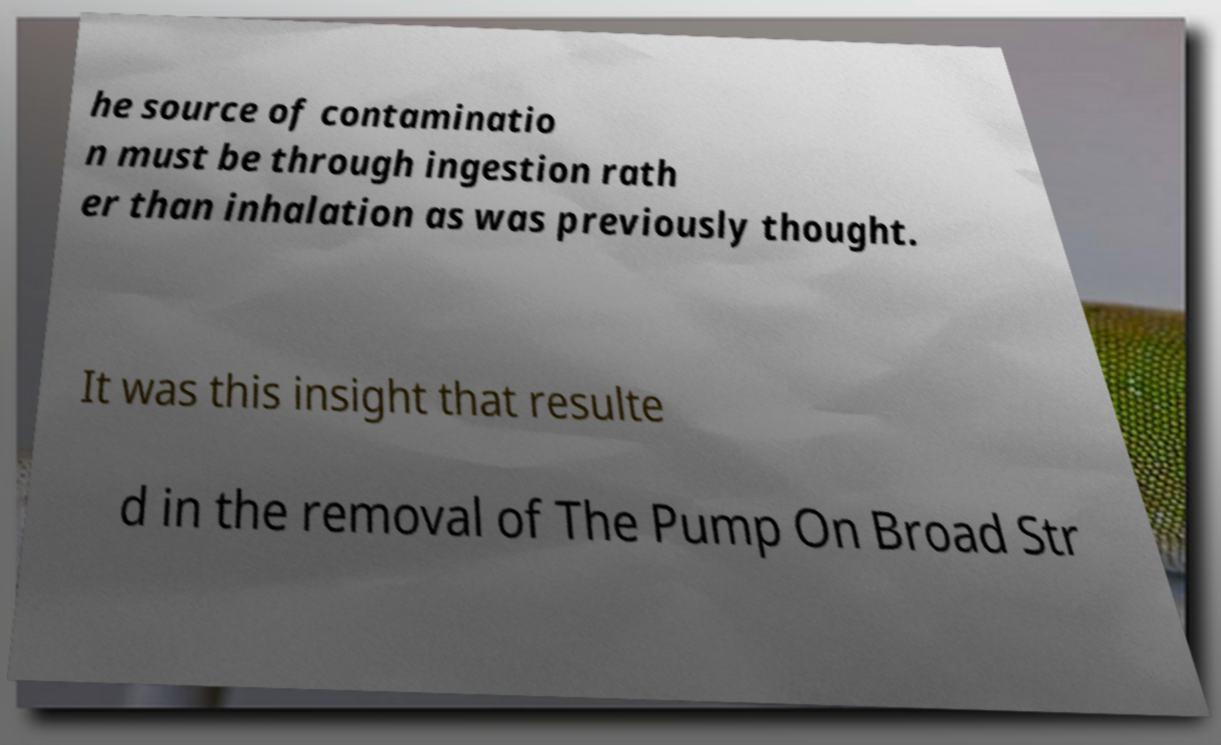Please identify and transcribe the text found in this image. he source of contaminatio n must be through ingestion rath er than inhalation as was previously thought. It was this insight that resulte d in the removal of The Pump On Broad Str 